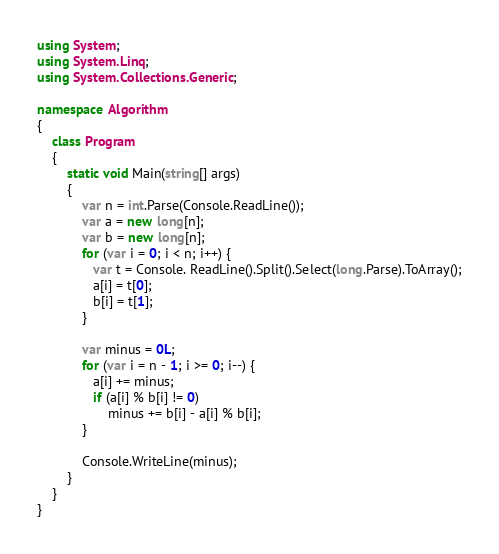Convert code to text. <code><loc_0><loc_0><loc_500><loc_500><_C#_>using System;
using System.Linq;
using System.Collections.Generic;

namespace Algorithm
{
    class Program
    {
        static void Main(string[] args)
        {
            var n = int.Parse(Console.ReadLine());
            var a = new long[n];
            var b = new long[n];
            for (var i = 0; i < n; i++) {
               var t = Console. ReadLine().Split().Select(long.Parse).ToArray();
               a[i] = t[0];
               b[i] = t[1];
            }
            
            var minus = 0L;
            for (var i = n - 1; i >= 0; i--) {
               a[i] += minus;
               if (a[i] % b[i] != 0)
                   minus += b[i] - a[i] % b[i];
            }
            
            Console.WriteLine(minus);
        }
    }
}
</code> 